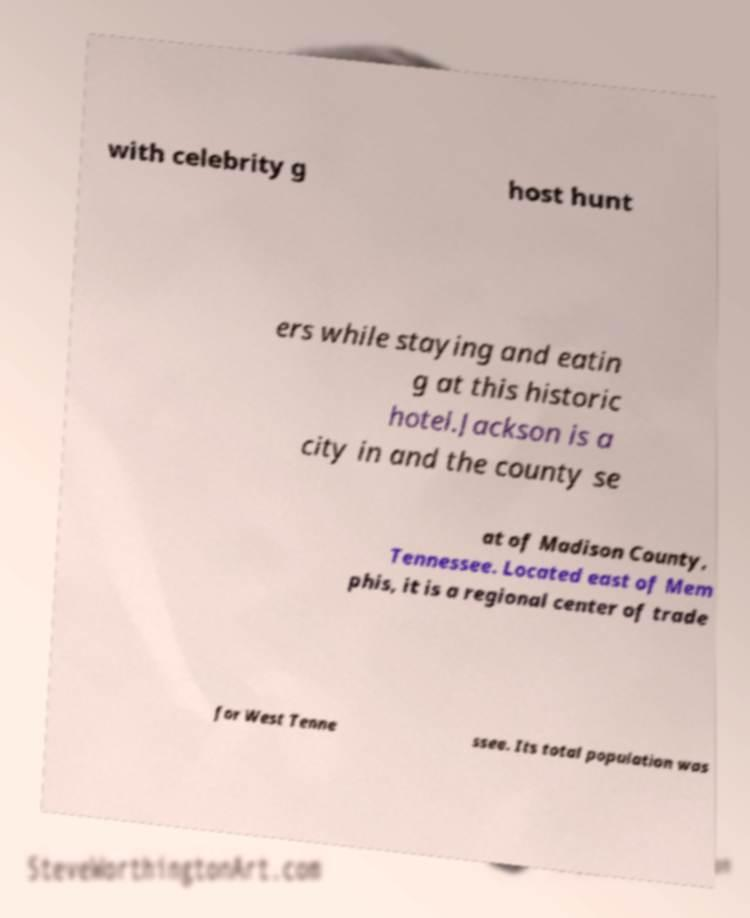Can you accurately transcribe the text from the provided image for me? with celebrity g host hunt ers while staying and eatin g at this historic hotel.Jackson is a city in and the county se at of Madison County, Tennessee. Located east of Mem phis, it is a regional center of trade for West Tenne ssee. Its total population was 